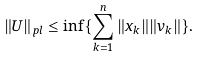Convert formula to latex. <formula><loc_0><loc_0><loc_500><loc_500>\| U \| _ { p l } \leq \inf \{ \sum _ { k = 1 } ^ { n } \| x _ { k } \| \| v _ { k } \| \} .</formula> 